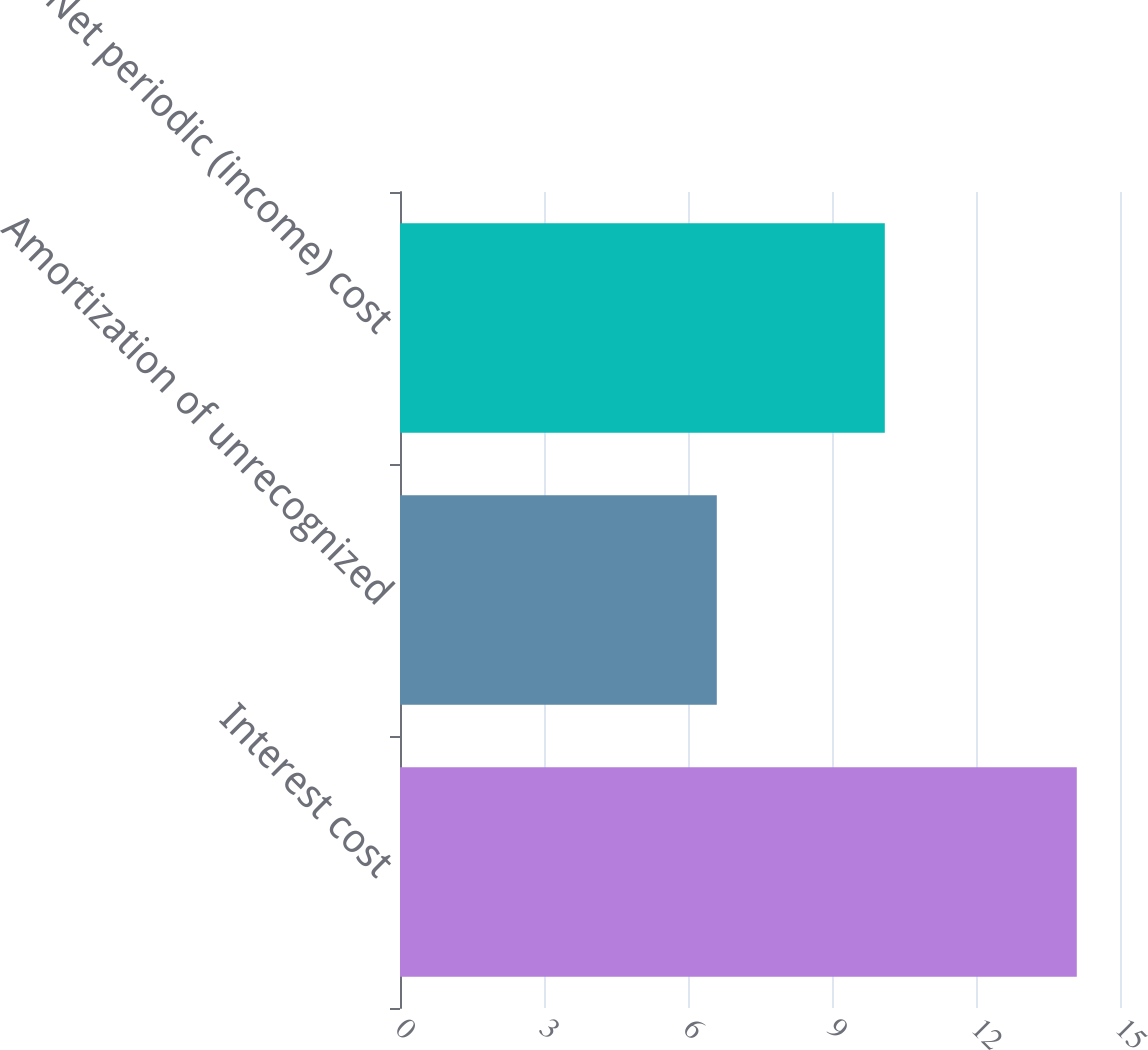Convert chart to OTSL. <chart><loc_0><loc_0><loc_500><loc_500><bar_chart><fcel>Interest cost<fcel>Amortization of unrecognized<fcel>Net periodic (income) cost<nl><fcel>14.1<fcel>6.6<fcel>10.1<nl></chart> 